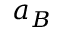<formula> <loc_0><loc_0><loc_500><loc_500>a _ { B }</formula> 